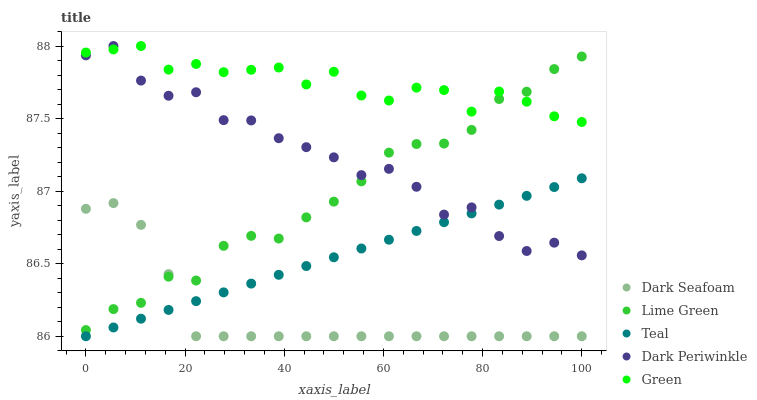Does Dark Seafoam have the minimum area under the curve?
Answer yes or no. Yes. Does Green have the maximum area under the curve?
Answer yes or no. Yes. Does Lime Green have the minimum area under the curve?
Answer yes or no. No. Does Lime Green have the maximum area under the curve?
Answer yes or no. No. Is Teal the smoothest?
Answer yes or no. Yes. Is Dark Periwinkle the roughest?
Answer yes or no. Yes. Is Dark Seafoam the smoothest?
Answer yes or no. No. Is Dark Seafoam the roughest?
Answer yes or no. No. Does Dark Seafoam have the lowest value?
Answer yes or no. Yes. Does Lime Green have the lowest value?
Answer yes or no. No. Does Dark Periwinkle have the highest value?
Answer yes or no. Yes. Does Lime Green have the highest value?
Answer yes or no. No. Is Teal less than Lime Green?
Answer yes or no. Yes. Is Green greater than Dark Seafoam?
Answer yes or no. Yes. Does Lime Green intersect Green?
Answer yes or no. Yes. Is Lime Green less than Green?
Answer yes or no. No. Is Lime Green greater than Green?
Answer yes or no. No. Does Teal intersect Lime Green?
Answer yes or no. No. 